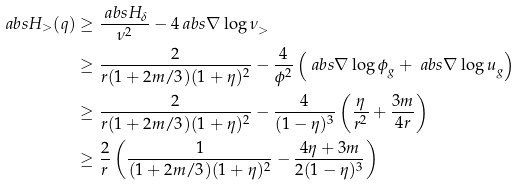Convert formula to latex. <formula><loc_0><loc_0><loc_500><loc_500>\ a b s { H _ { > } ( q ) } & \geq \frac { \ a b s { H _ { \delta } } } { \nu ^ { 2 } } - 4 \ a b s { \nabla \log \nu } _ { > } \\ & \geq \frac { 2 } { r ( 1 + 2 m / 3 ) ( 1 + \eta ) ^ { 2 } } - \frac { 4 } { \phi ^ { 2 } } \left ( \ a b s { \nabla \log \phi } _ { g } + \ a b s { \nabla \log u } _ { g } \right ) \\ & \geq \frac { 2 } { r ( 1 + 2 m / 3 ) ( 1 + \eta ) ^ { 2 } } - \frac { 4 } { ( 1 - \eta ) ^ { 3 } } \left ( \frac { \eta } { r ^ { 2 } } + \frac { 3 m } { 4 r } \right ) \\ & \geq \frac { 2 } { r } \left ( \frac { 1 } { ( 1 + 2 m / 3 ) ( 1 + \eta ) ^ { 2 } } - \frac { 4 \eta + 3 m } { 2 ( 1 - \eta ) ^ { 3 } } \right )</formula> 